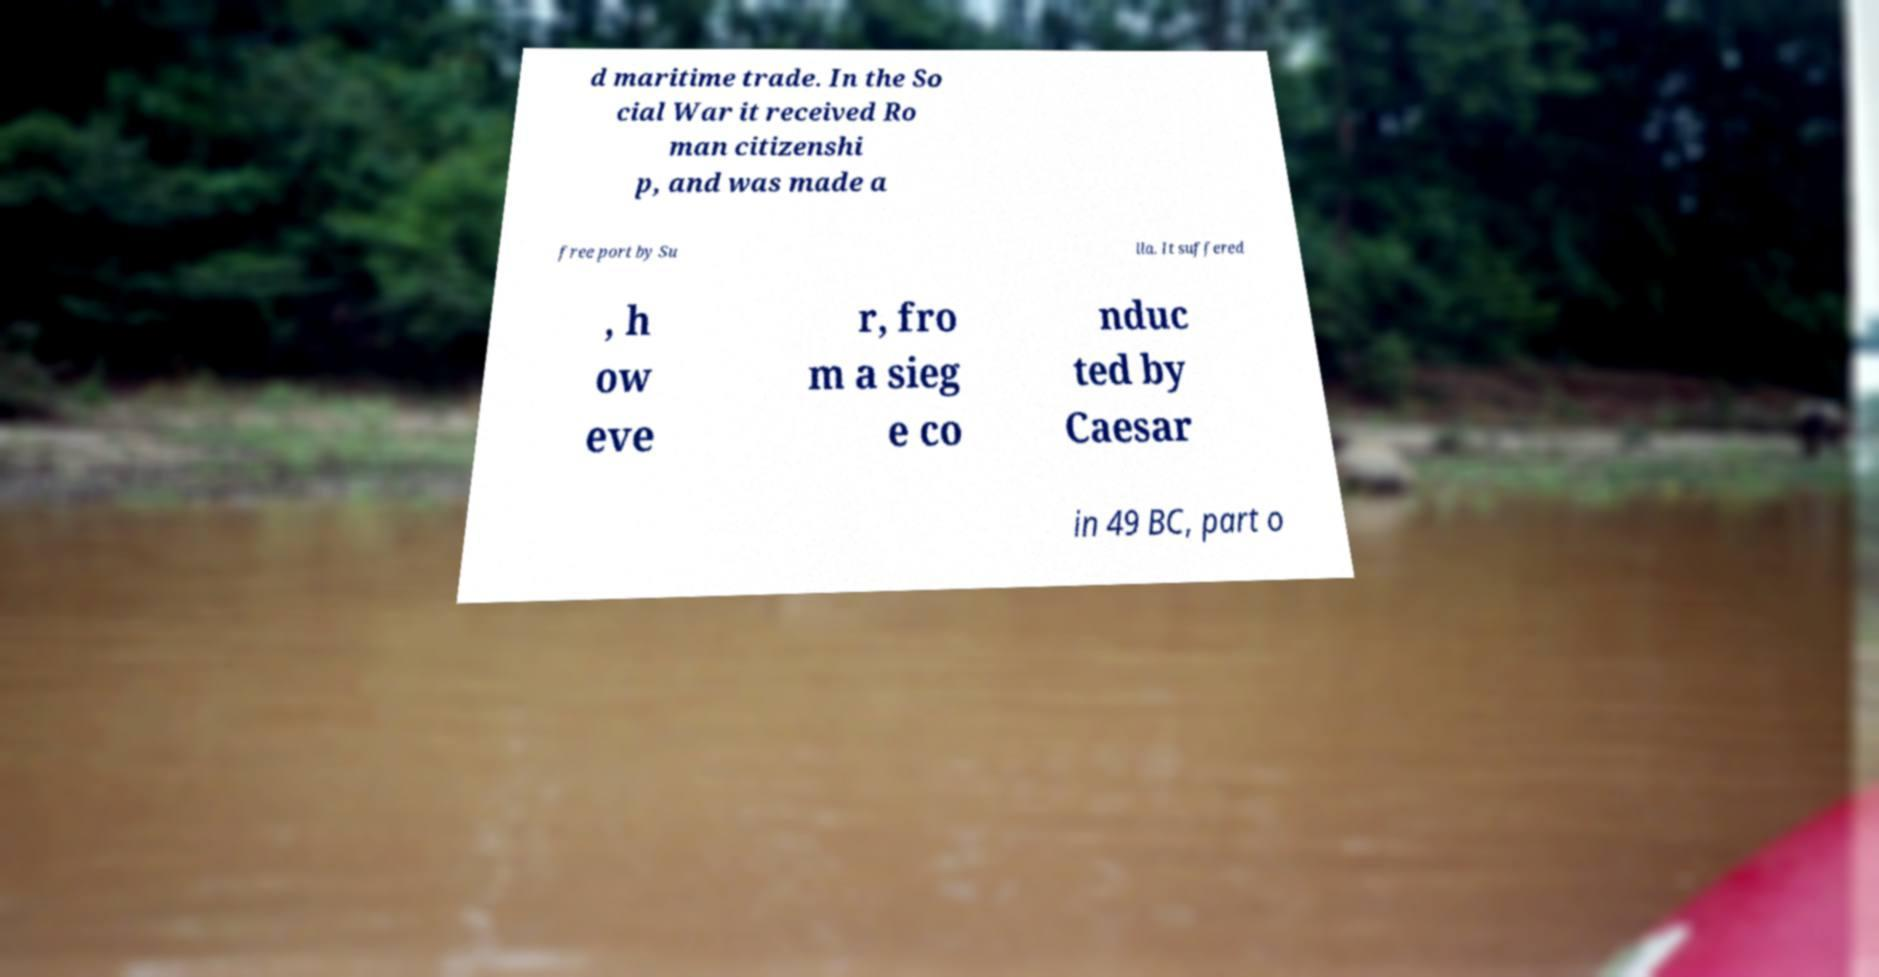There's text embedded in this image that I need extracted. Can you transcribe it verbatim? d maritime trade. In the So cial War it received Ro man citizenshi p, and was made a free port by Su lla. It suffered , h ow eve r, fro m a sieg e co nduc ted by Caesar in 49 BC, part o 